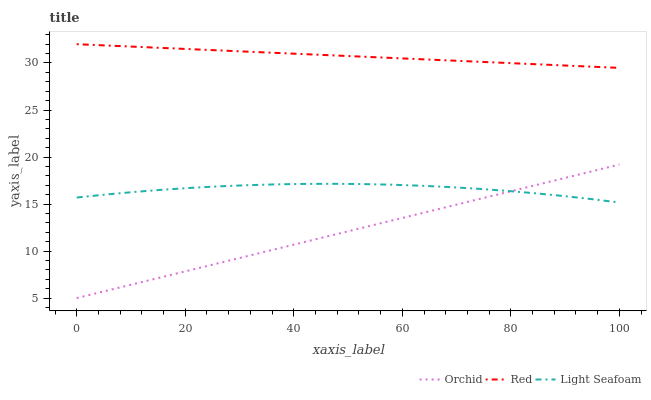Does Orchid have the minimum area under the curve?
Answer yes or no. Yes. Does Red have the maximum area under the curve?
Answer yes or no. Yes. Does Red have the minimum area under the curve?
Answer yes or no. No. Does Orchid have the maximum area under the curve?
Answer yes or no. No. Is Orchid the smoothest?
Answer yes or no. Yes. Is Light Seafoam the roughest?
Answer yes or no. Yes. Is Red the smoothest?
Answer yes or no. No. Is Red the roughest?
Answer yes or no. No. Does Orchid have the lowest value?
Answer yes or no. Yes. Does Red have the lowest value?
Answer yes or no. No. Does Red have the highest value?
Answer yes or no. Yes. Does Orchid have the highest value?
Answer yes or no. No. Is Light Seafoam less than Red?
Answer yes or no. Yes. Is Red greater than Light Seafoam?
Answer yes or no. Yes. Does Light Seafoam intersect Orchid?
Answer yes or no. Yes. Is Light Seafoam less than Orchid?
Answer yes or no. No. Is Light Seafoam greater than Orchid?
Answer yes or no. No. Does Light Seafoam intersect Red?
Answer yes or no. No. 